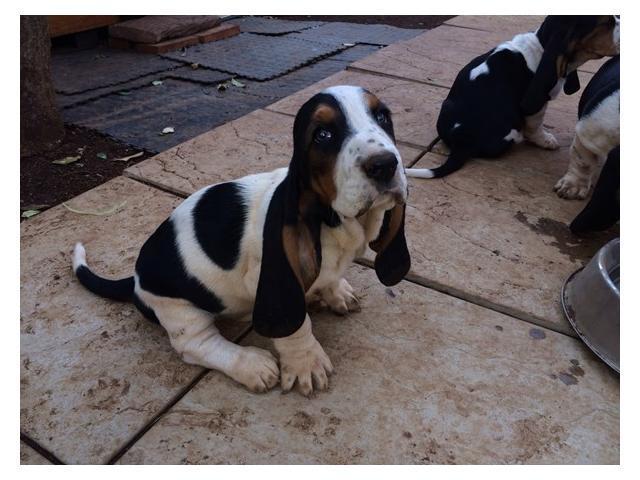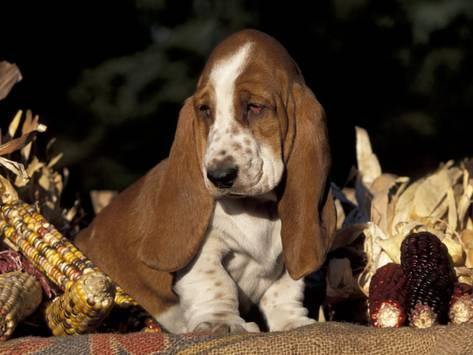The first image is the image on the left, the second image is the image on the right. Analyze the images presented: Is the assertion "There are no less than five dogs" valid? Answer yes or no. No. The first image is the image on the left, the second image is the image on the right. Assess this claim about the two images: "Right image shows exactly three basset hounds.". Correct or not? Answer yes or no. No. 